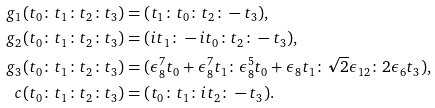<formula> <loc_0><loc_0><loc_500><loc_500>g _ { 1 } ( t _ { 0 } \colon t _ { 1 } \colon t _ { 2 } \colon t _ { 3 } ) & = ( t _ { 1 } \colon t _ { 0 } \colon t _ { 2 } \colon - t _ { 3 } ) , \\ g _ { 2 } ( t _ { 0 } \colon t _ { 1 } \colon t _ { 2 } \colon t _ { 3 } ) & = ( i t _ { 1 } \colon - i t _ { 0 } \colon t _ { 2 } \colon - t _ { 3 } ) , \\ g _ { 3 } ( t _ { 0 } \colon t _ { 1 } \colon t _ { 2 } \colon t _ { 3 } ) & = ( \epsilon _ { 8 } ^ { 7 } t _ { 0 } + \epsilon _ { 8 } ^ { 7 } t _ { 1 } \colon \epsilon _ { 8 } ^ { 5 } t _ { 0 } + \epsilon _ { 8 } t _ { 1 } \colon \sqrt { 2 } \epsilon _ { 1 2 } \colon 2 \epsilon _ { 6 } t _ { 3 } ) , \\ c ( t _ { 0 } \colon t _ { 1 } \colon t _ { 2 } \colon t _ { 3 } ) & = ( t _ { 0 } \colon t _ { 1 } \colon i t _ { 2 } \colon - t _ { 3 } ) .</formula> 